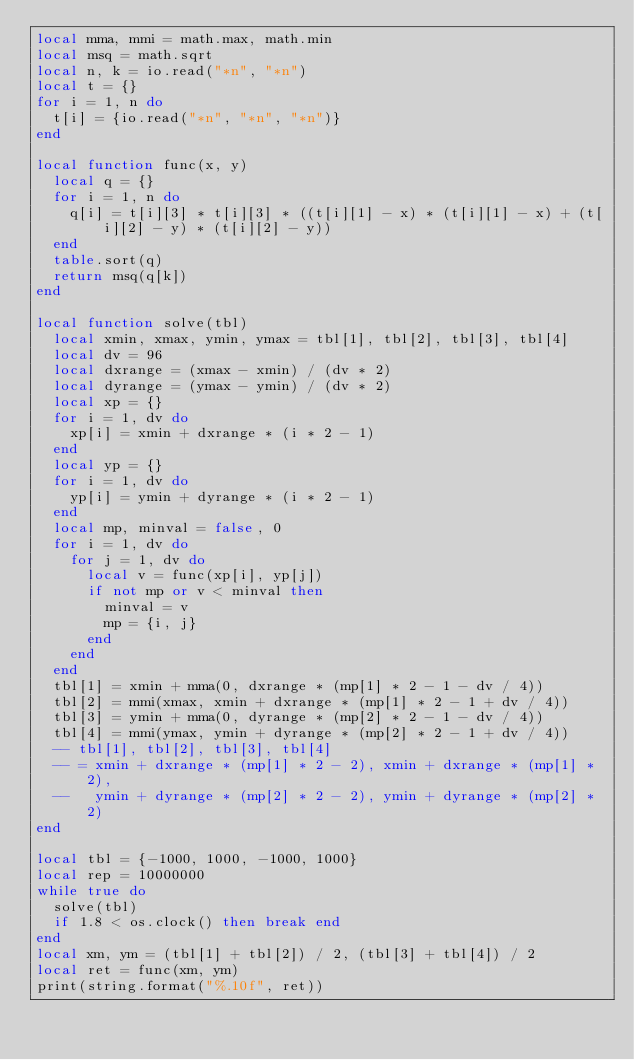Convert code to text. <code><loc_0><loc_0><loc_500><loc_500><_Lua_>local mma, mmi = math.max, math.min
local msq = math.sqrt
local n, k = io.read("*n", "*n")
local t = {}
for i = 1, n do
  t[i] = {io.read("*n", "*n", "*n")}
end

local function func(x, y)
  local q = {}
  for i = 1, n do
    q[i] = t[i][3] * t[i][3] * ((t[i][1] - x) * (t[i][1] - x) + (t[i][2] - y) * (t[i][2] - y))
  end
  table.sort(q)
  return msq(q[k])
end

local function solve(tbl)
  local xmin, xmax, ymin, ymax = tbl[1], tbl[2], tbl[3], tbl[4]
  local dv = 96
  local dxrange = (xmax - xmin) / (dv * 2)
  local dyrange = (ymax - ymin) / (dv * 2)
  local xp = {}
  for i = 1, dv do
    xp[i] = xmin + dxrange * (i * 2 - 1)
  end
  local yp = {}
  for i = 1, dv do
    yp[i] = ymin + dyrange * (i * 2 - 1)
  end
  local mp, minval = false, 0
  for i = 1, dv do
    for j = 1, dv do
      local v = func(xp[i], yp[j])
      if not mp or v < minval then
        minval = v
        mp = {i, j}
      end
    end
  end
  tbl[1] = xmin + mma(0, dxrange * (mp[1] * 2 - 1 - dv / 4))
  tbl[2] = mmi(xmax, xmin + dxrange * (mp[1] * 2 - 1 + dv / 4))
  tbl[3] = ymin + mma(0, dyrange * (mp[2] * 2 - 1 - dv / 4))
  tbl[4] = mmi(ymax, ymin + dyrange * (mp[2] * 2 - 1 + dv / 4))
  -- tbl[1], tbl[2], tbl[3], tbl[4]
  -- = xmin + dxrange * (mp[1] * 2 - 2), xmin + dxrange * (mp[1] * 2),
  --   ymin + dyrange * (mp[2] * 2 - 2), ymin + dyrange * (mp[2] * 2)
end

local tbl = {-1000, 1000, -1000, 1000}
local rep = 10000000
while true do
  solve(tbl)
  if 1.8 < os.clock() then break end
end
local xm, ym = (tbl[1] + tbl[2]) / 2, (tbl[3] + tbl[4]) / 2
local ret = func(xm, ym)
print(string.format("%.10f", ret))
</code> 